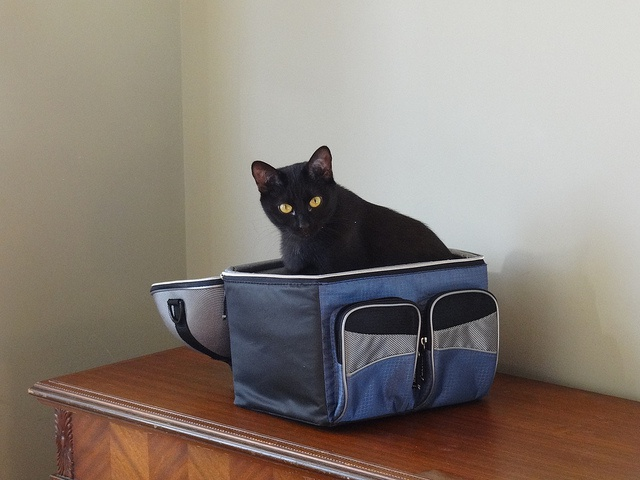Describe the objects in this image and their specific colors. I can see suitcase in tan, black, gray, and darkblue tones and cat in tan, black, gray, and maroon tones in this image. 